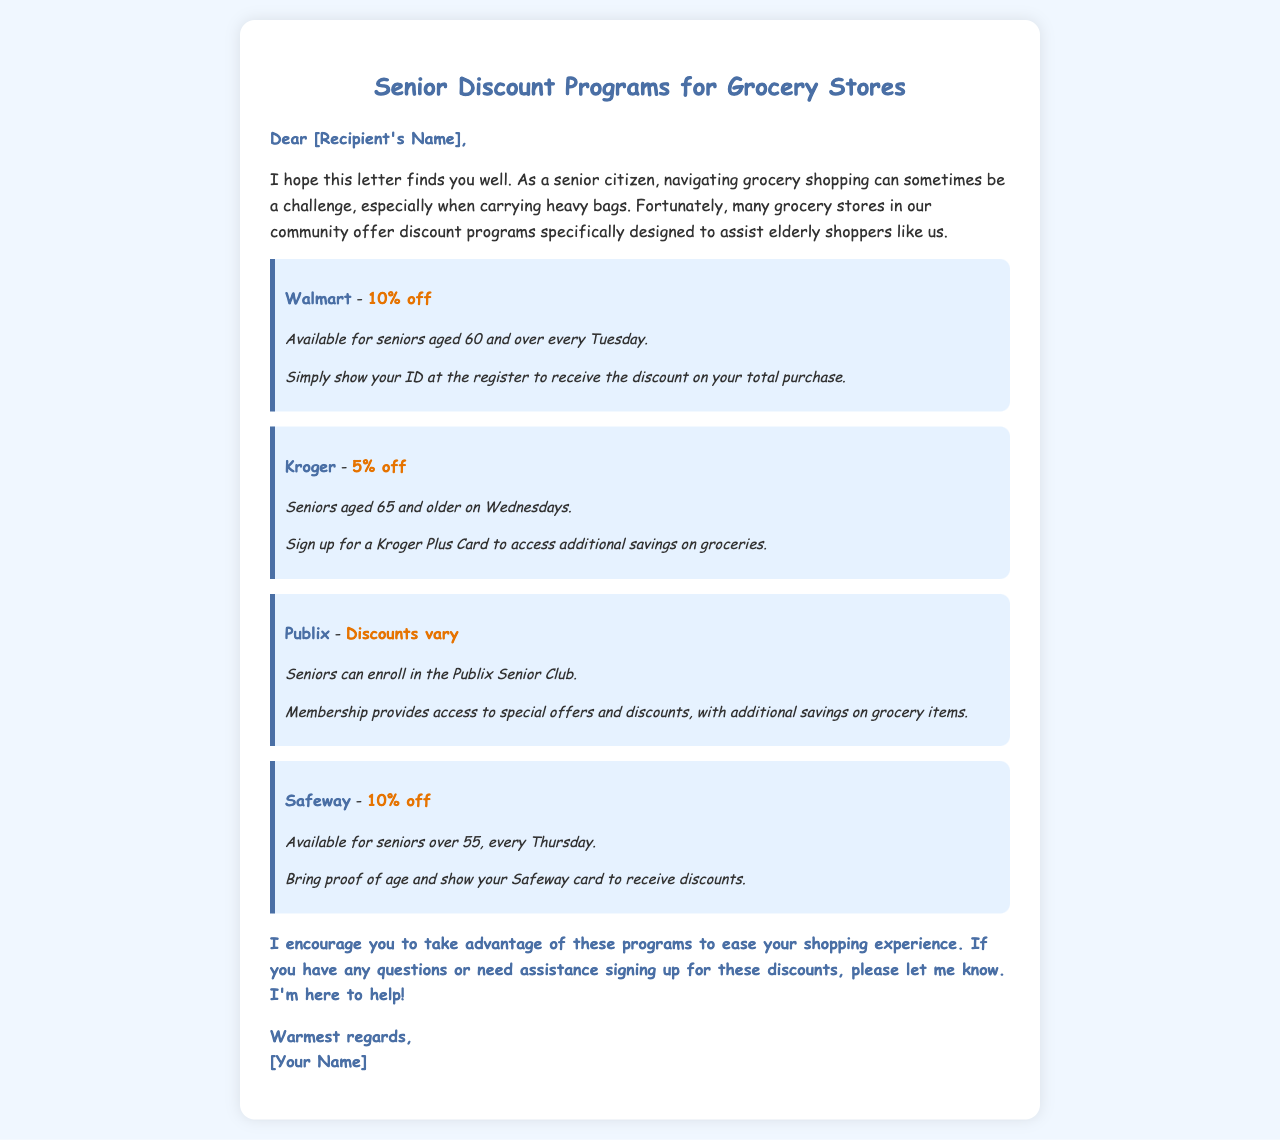What is the discount at Walmart? The Walmart discount for seniors is stated as 10% off.
Answer: 10% off On which day can seniors shop at Kroger for a discount? The document specifies that seniors can shop at Kroger for a discount on Wednesdays.
Answer: Wednesdays What is the eligibility age for the Safeway discount? The eligibility age for the Safeway discount is provided as seniors over 55.
Answer: over 55 What must seniors show at the register to receive the Walmart discount? The document mentions that seniors must show their ID at the register to receive the Walmart discount.
Answer: ID How can seniors access additional savings at Kroger? Seniors can sign up for a Kroger Plus Card to access additional savings.
Answer: Kroger Plus Card What is the purpose of the Publix Senior Club? The document states that the Publix Senior Club provides access to special offers and discounts.
Answer: special offers and discounts What is the discount percentage at Safeway? The discount percentage offered by Safeway for seniors is stated in the document as 10% off.
Answer: 10% off What day of the week is the Walmart discount available? The document indicates that the Walmart discount is available every Tuesday.
Answer: Tuesday Who is encouraged to take advantage of these programs? The writer encourages seniors to take advantage of these programs in the letter.
Answer: seniors 